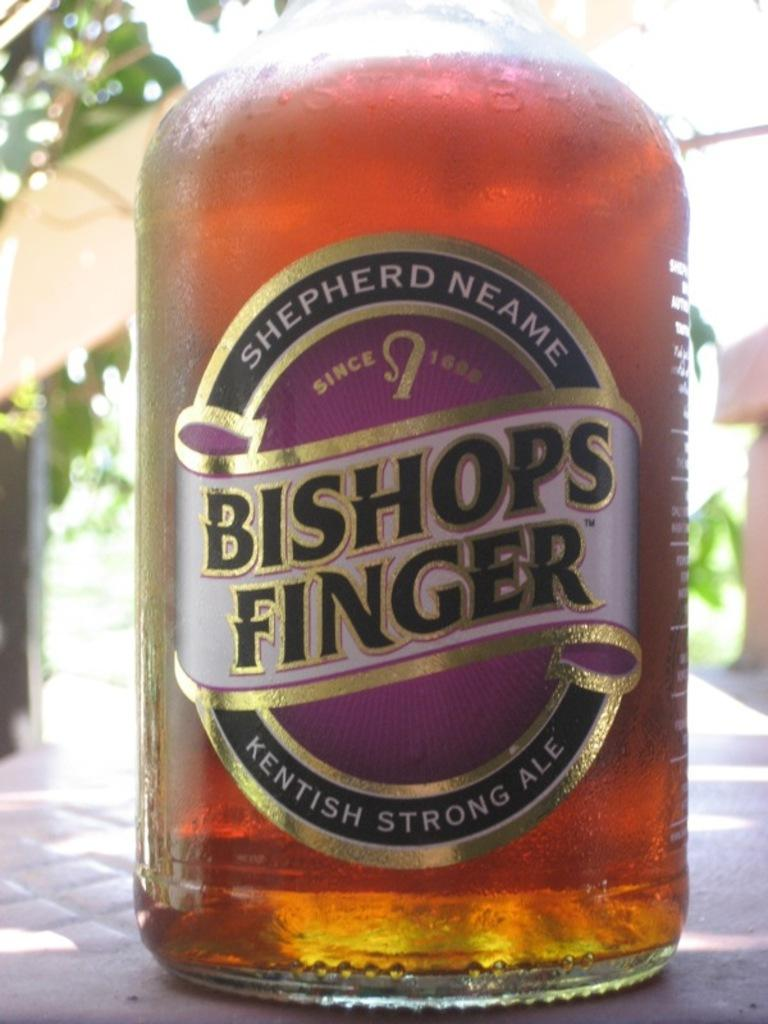What object can be seen in the image? There is a bottle in the image. What is written on the bottle? The bottle has "Bishop's Finger" written on it. What is the color of the liquid inside the bottle? The liquid in the bottle is red in color. What type of eye is visible in the image? There is no eye present in the image; it features a bottle with red liquid and the label "Bishop's Finger." 